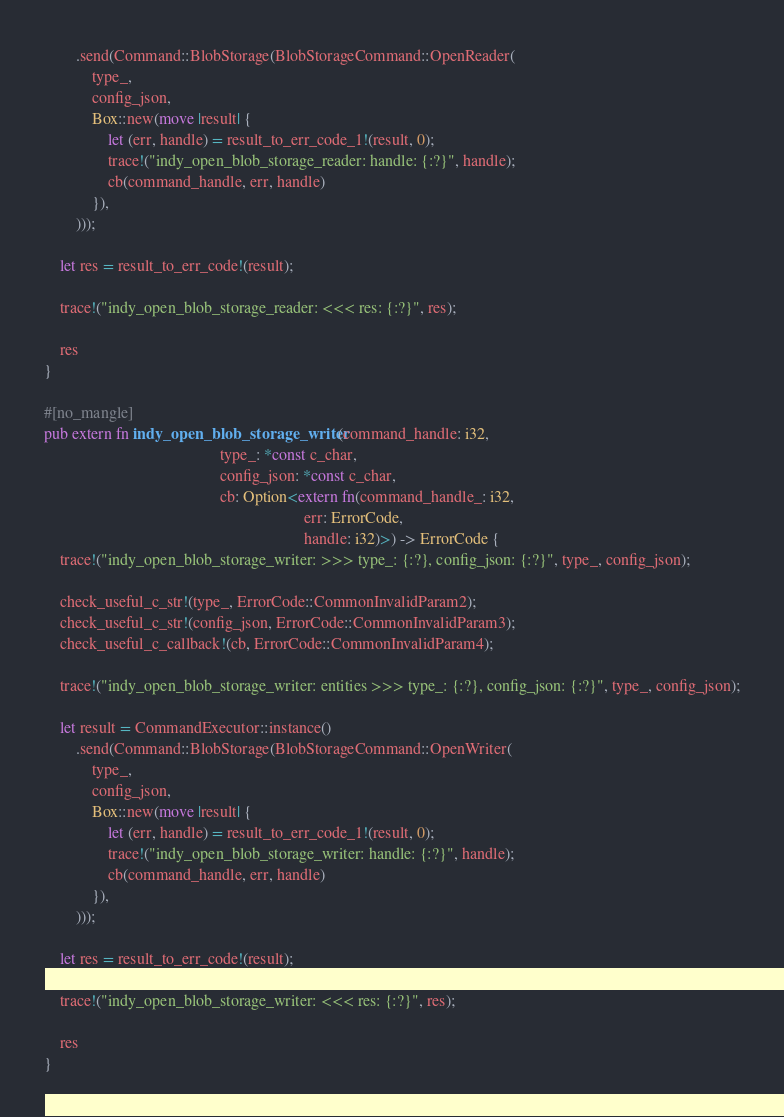<code> <loc_0><loc_0><loc_500><loc_500><_Rust_>        .send(Command::BlobStorage(BlobStorageCommand::OpenReader(
            type_,
            config_json,
            Box::new(move |result| {
                let (err, handle) = result_to_err_code_1!(result, 0);
                trace!("indy_open_blob_storage_reader: handle: {:?}", handle);
                cb(command_handle, err, handle)
            }),
        )));

    let res = result_to_err_code!(result);

    trace!("indy_open_blob_storage_reader: <<< res: {:?}", res);

    res
}

#[no_mangle]
pub extern fn indy_open_blob_storage_writer(command_handle: i32,
                                            type_: *const c_char,
                                            config_json: *const c_char,
                                            cb: Option<extern fn(command_handle_: i32,
                                                                 err: ErrorCode,
                                                                 handle: i32)>) -> ErrorCode {
    trace!("indy_open_blob_storage_writer: >>> type_: {:?}, config_json: {:?}", type_, config_json);

    check_useful_c_str!(type_, ErrorCode::CommonInvalidParam2);
    check_useful_c_str!(config_json, ErrorCode::CommonInvalidParam3);
    check_useful_c_callback!(cb, ErrorCode::CommonInvalidParam4);

    trace!("indy_open_blob_storage_writer: entities >>> type_: {:?}, config_json: {:?}", type_, config_json);

    let result = CommandExecutor::instance()
        .send(Command::BlobStorage(BlobStorageCommand::OpenWriter(
            type_,
            config_json,
            Box::new(move |result| {
                let (err, handle) = result_to_err_code_1!(result, 0);
                trace!("indy_open_blob_storage_writer: handle: {:?}", handle);
                cb(command_handle, err, handle)
            }),
        )));

    let res = result_to_err_code!(result);

    trace!("indy_open_blob_storage_writer: <<< res: {:?}", res);

    res
}
</code> 